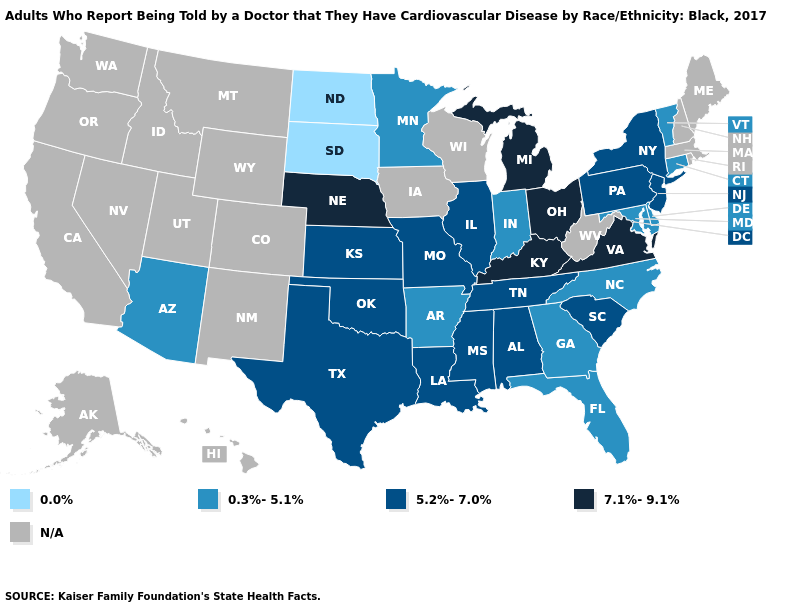Which states have the lowest value in the USA?
Keep it brief. North Dakota, South Dakota. What is the value of Nevada?
Give a very brief answer. N/A. What is the highest value in the South ?
Quick response, please. 7.1%-9.1%. What is the highest value in the South ?
Write a very short answer. 7.1%-9.1%. What is the lowest value in the MidWest?
Concise answer only. 0.0%. What is the value of Washington?
Answer briefly. N/A. Does Ohio have the highest value in the USA?
Short answer required. Yes. How many symbols are there in the legend?
Quick response, please. 5. Which states hav the highest value in the Northeast?
Quick response, please. New Jersey, New York, Pennsylvania. Name the states that have a value in the range 5.2%-7.0%?
Answer briefly. Alabama, Illinois, Kansas, Louisiana, Mississippi, Missouri, New Jersey, New York, Oklahoma, Pennsylvania, South Carolina, Tennessee, Texas. What is the value of Louisiana?
Short answer required. 5.2%-7.0%. Does Connecticut have the lowest value in the Northeast?
Write a very short answer. Yes. Name the states that have a value in the range N/A?
Give a very brief answer. Alaska, California, Colorado, Hawaii, Idaho, Iowa, Maine, Massachusetts, Montana, Nevada, New Hampshire, New Mexico, Oregon, Rhode Island, Utah, Washington, West Virginia, Wisconsin, Wyoming. 